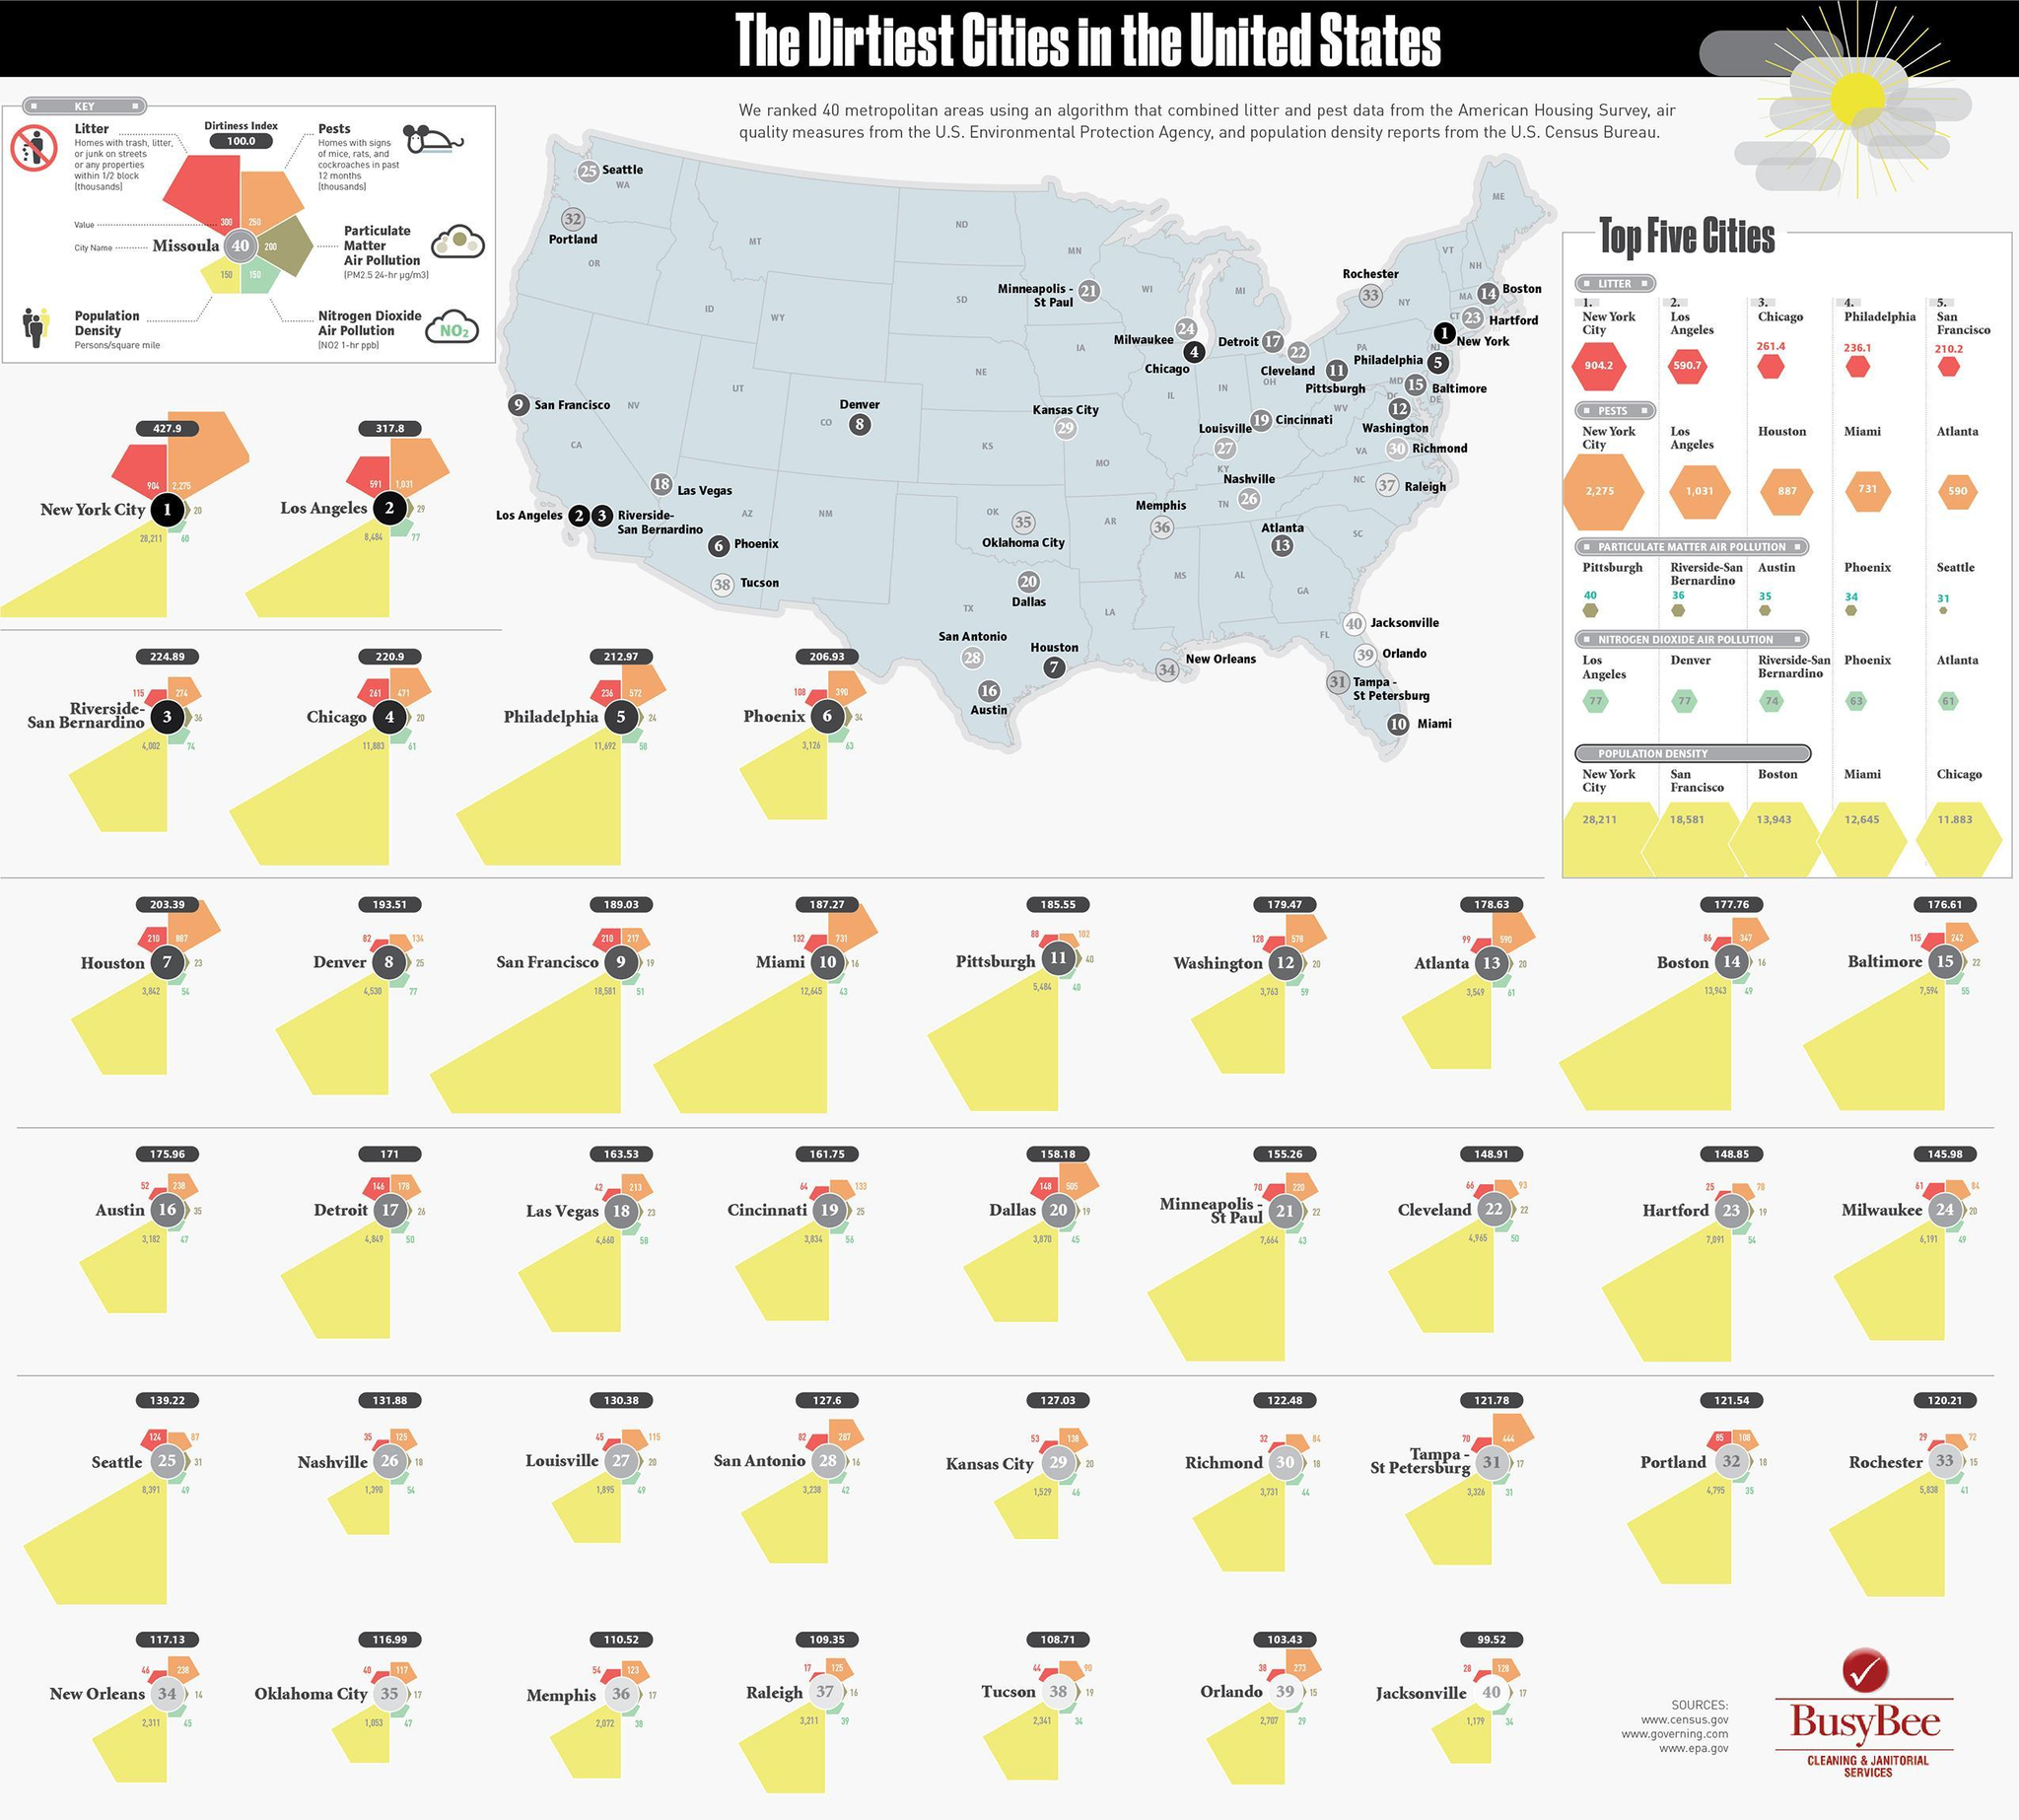What is the Nitrogen Dioxide Air Pollution value for Kansas City?
Answer the question with a short phrase. 46 What is the dirtiness index value for Orlando? 103.43 What is the population density of Detroit? 4,849 What is the dirtiness index value for Atlanta? 178.63 What is the particulate matter air pollution value for Dallas? 19 What is the value corresponding to litter for Phoenix? 108 What is the value corresponding to pests for Tucson? 90 Which city has third highest particulate matter air pollution? Austin Which city has second highest nitrogen dioxide air pollution? Denver What is the population density of Memphis? 2,072 